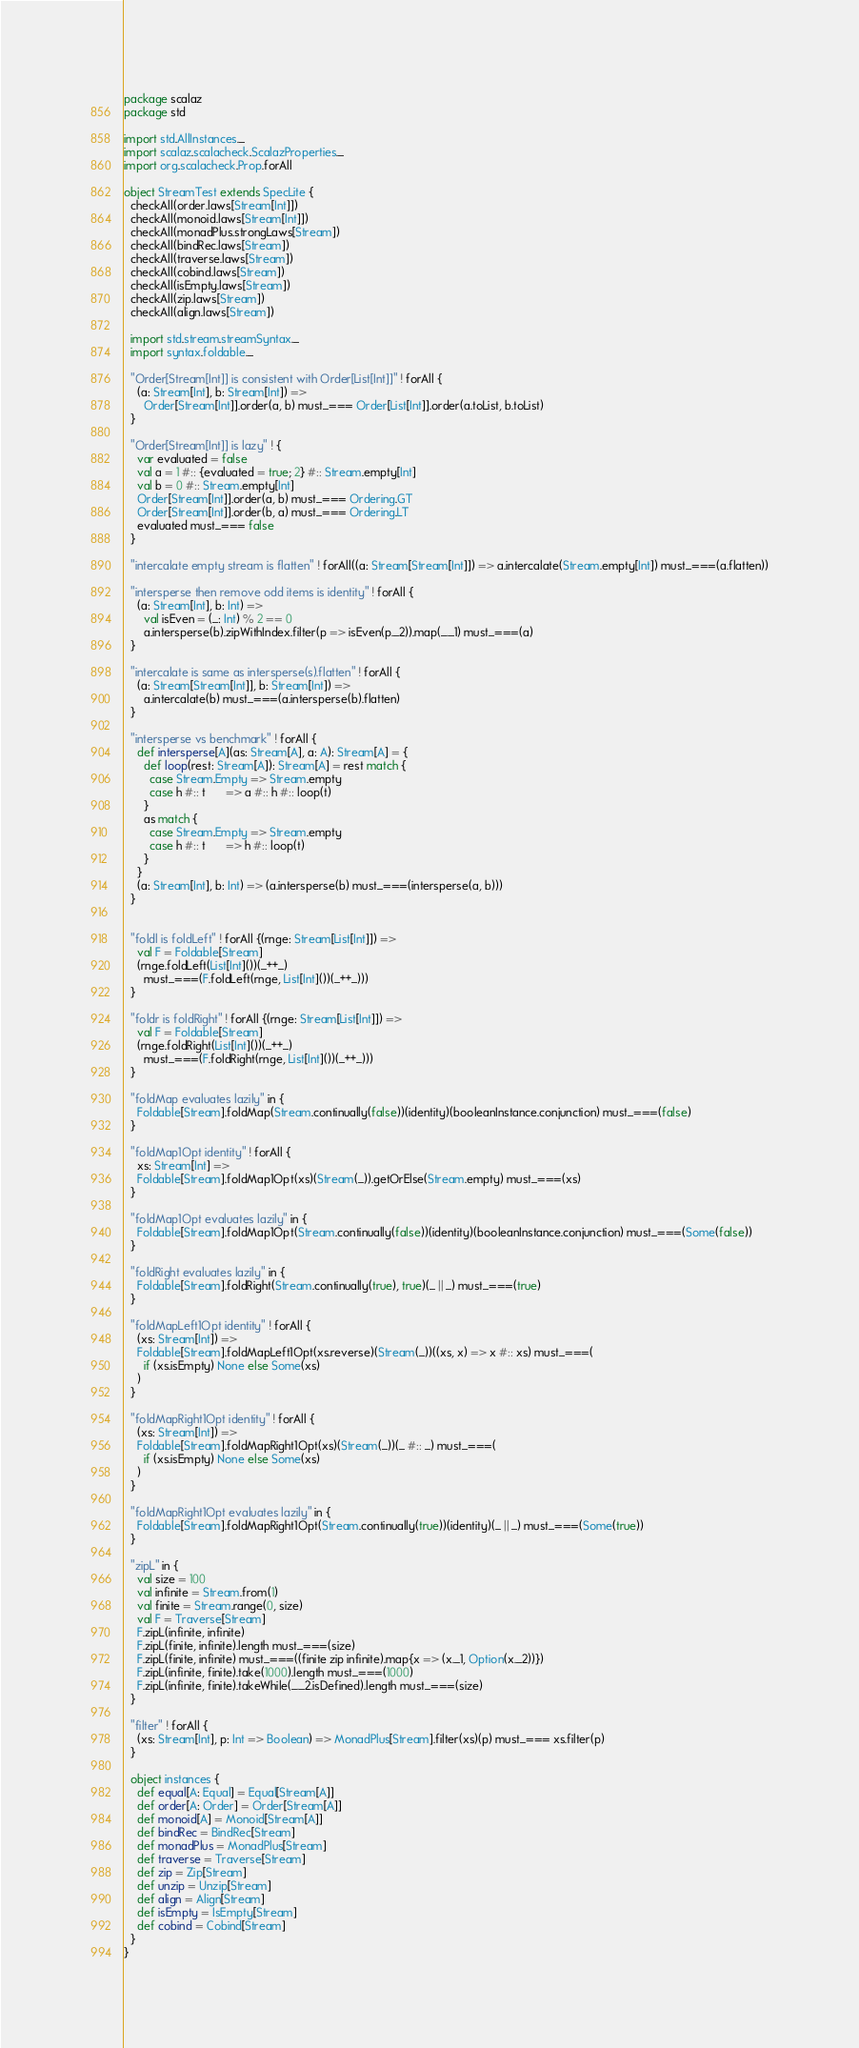<code> <loc_0><loc_0><loc_500><loc_500><_Scala_>package scalaz
package std

import std.AllInstances._
import scalaz.scalacheck.ScalazProperties._
import org.scalacheck.Prop.forAll

object StreamTest extends SpecLite {
  checkAll(order.laws[Stream[Int]])
  checkAll(monoid.laws[Stream[Int]])
  checkAll(monadPlus.strongLaws[Stream])
  checkAll(bindRec.laws[Stream])
  checkAll(traverse.laws[Stream])
  checkAll(cobind.laws[Stream])
  checkAll(isEmpty.laws[Stream])
  checkAll(zip.laws[Stream])
  checkAll(align.laws[Stream])

  import std.stream.streamSyntax._
  import syntax.foldable._

  "Order[Stream[Int]] is consistent with Order[List[Int]]" ! forAll {
    (a: Stream[Int], b: Stream[Int]) =>
      Order[Stream[Int]].order(a, b) must_=== Order[List[Int]].order(a.toList, b.toList)
  }

  "Order[Stream[Int]] is lazy" ! {
    var evaluated = false
    val a = 1 #:: {evaluated = true; 2} #:: Stream.empty[Int]
    val b = 0 #:: Stream.empty[Int]
    Order[Stream[Int]].order(a, b) must_=== Ordering.GT
    Order[Stream[Int]].order(b, a) must_=== Ordering.LT
    evaluated must_=== false
  }

  "intercalate empty stream is flatten" ! forAll((a: Stream[Stream[Int]]) => a.intercalate(Stream.empty[Int]) must_===(a.flatten))

  "intersperse then remove odd items is identity" ! forAll {
    (a: Stream[Int], b: Int) =>
      val isEven = (_: Int) % 2 == 0
      a.intersperse(b).zipWithIndex.filter(p => isEven(p._2)).map(_._1) must_===(a)
  }

  "intercalate is same as intersperse(s).flatten" ! forAll {
    (a: Stream[Stream[Int]], b: Stream[Int]) =>
      a.intercalate(b) must_===(a.intersperse(b).flatten)
  }

  "intersperse vs benchmark" ! forAll {
    def intersperse[A](as: Stream[A], a: A): Stream[A] = {
      def loop(rest: Stream[A]): Stream[A] = rest match {
        case Stream.Empty => Stream.empty
        case h #:: t      => a #:: h #:: loop(t)
      }
      as match {
        case Stream.Empty => Stream.empty
        case h #:: t      => h #:: loop(t)
      }
    }
    (a: Stream[Int], b: Int) => (a.intersperse(b) must_===(intersperse(a, b)))
  }


  "foldl is foldLeft" ! forAll {(rnge: Stream[List[Int]]) =>
    val F = Foldable[Stream]
    (rnge.foldLeft(List[Int]())(_++_)
      must_===(F.foldLeft(rnge, List[Int]())(_++_)))
  }

  "foldr is foldRight" ! forAll {(rnge: Stream[List[Int]]) =>
    val F = Foldable[Stream]
    (rnge.foldRight(List[Int]())(_++_)
      must_===(F.foldRight(rnge, List[Int]())(_++_)))
  }

  "foldMap evaluates lazily" in {
    Foldable[Stream].foldMap(Stream.continually(false))(identity)(booleanInstance.conjunction) must_===(false)
  }

  "foldMap1Opt identity" ! forAll {
    xs: Stream[Int] =>
    Foldable[Stream].foldMap1Opt(xs)(Stream(_)).getOrElse(Stream.empty) must_===(xs)
  }

  "foldMap1Opt evaluates lazily" in {
    Foldable[Stream].foldMap1Opt(Stream.continually(false))(identity)(booleanInstance.conjunction) must_===(Some(false))
  }

  "foldRight evaluates lazily" in {
    Foldable[Stream].foldRight(Stream.continually(true), true)(_ || _) must_===(true)
  }

  "foldMapLeft1Opt identity" ! forAll {
    (xs: Stream[Int]) =>
    Foldable[Stream].foldMapLeft1Opt(xs.reverse)(Stream(_))((xs, x) => x #:: xs) must_===(
      if (xs.isEmpty) None else Some(xs)
    )
  }

  "foldMapRight1Opt identity" ! forAll {
    (xs: Stream[Int]) =>
    Foldable[Stream].foldMapRight1Opt(xs)(Stream(_))(_ #:: _) must_===(
      if (xs.isEmpty) None else Some(xs)
    )
  }

  "foldMapRight1Opt evaluates lazily" in {
    Foldable[Stream].foldMapRight1Opt(Stream.continually(true))(identity)(_ || _) must_===(Some(true))
  }

  "zipL" in {
    val size = 100
    val infinite = Stream.from(1)
    val finite = Stream.range(0, size)
    val F = Traverse[Stream]
    F.zipL(infinite, infinite)
    F.zipL(finite, infinite).length must_===(size)
    F.zipL(finite, infinite) must_===((finite zip infinite).map{x => (x._1, Option(x._2))})
    F.zipL(infinite, finite).take(1000).length must_===(1000)
    F.zipL(infinite, finite).takeWhile(_._2.isDefined).length must_===(size)
  }

  "filter" ! forAll {
    (xs: Stream[Int], p: Int => Boolean) => MonadPlus[Stream].filter(xs)(p) must_=== xs.filter(p)
  }

  object instances {
    def equal[A: Equal] = Equal[Stream[A]]
    def order[A: Order] = Order[Stream[A]]
    def monoid[A] = Monoid[Stream[A]]
    def bindRec = BindRec[Stream]
    def monadPlus = MonadPlus[Stream]
    def traverse = Traverse[Stream]
    def zip = Zip[Stream]
    def unzip = Unzip[Stream]
    def align = Align[Stream]
    def isEmpty = IsEmpty[Stream]
    def cobind = Cobind[Stream]
  }
}
</code> 